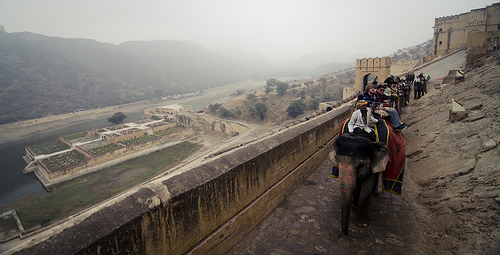Describe the types of activities visible in this image. The image prominently shows elephant riding as a tourist activity along a historical fort path. Behind, there's a large garden and a water body that might serve either as additional tourist attractions or as parts of the fort's ancient irrigation system. 